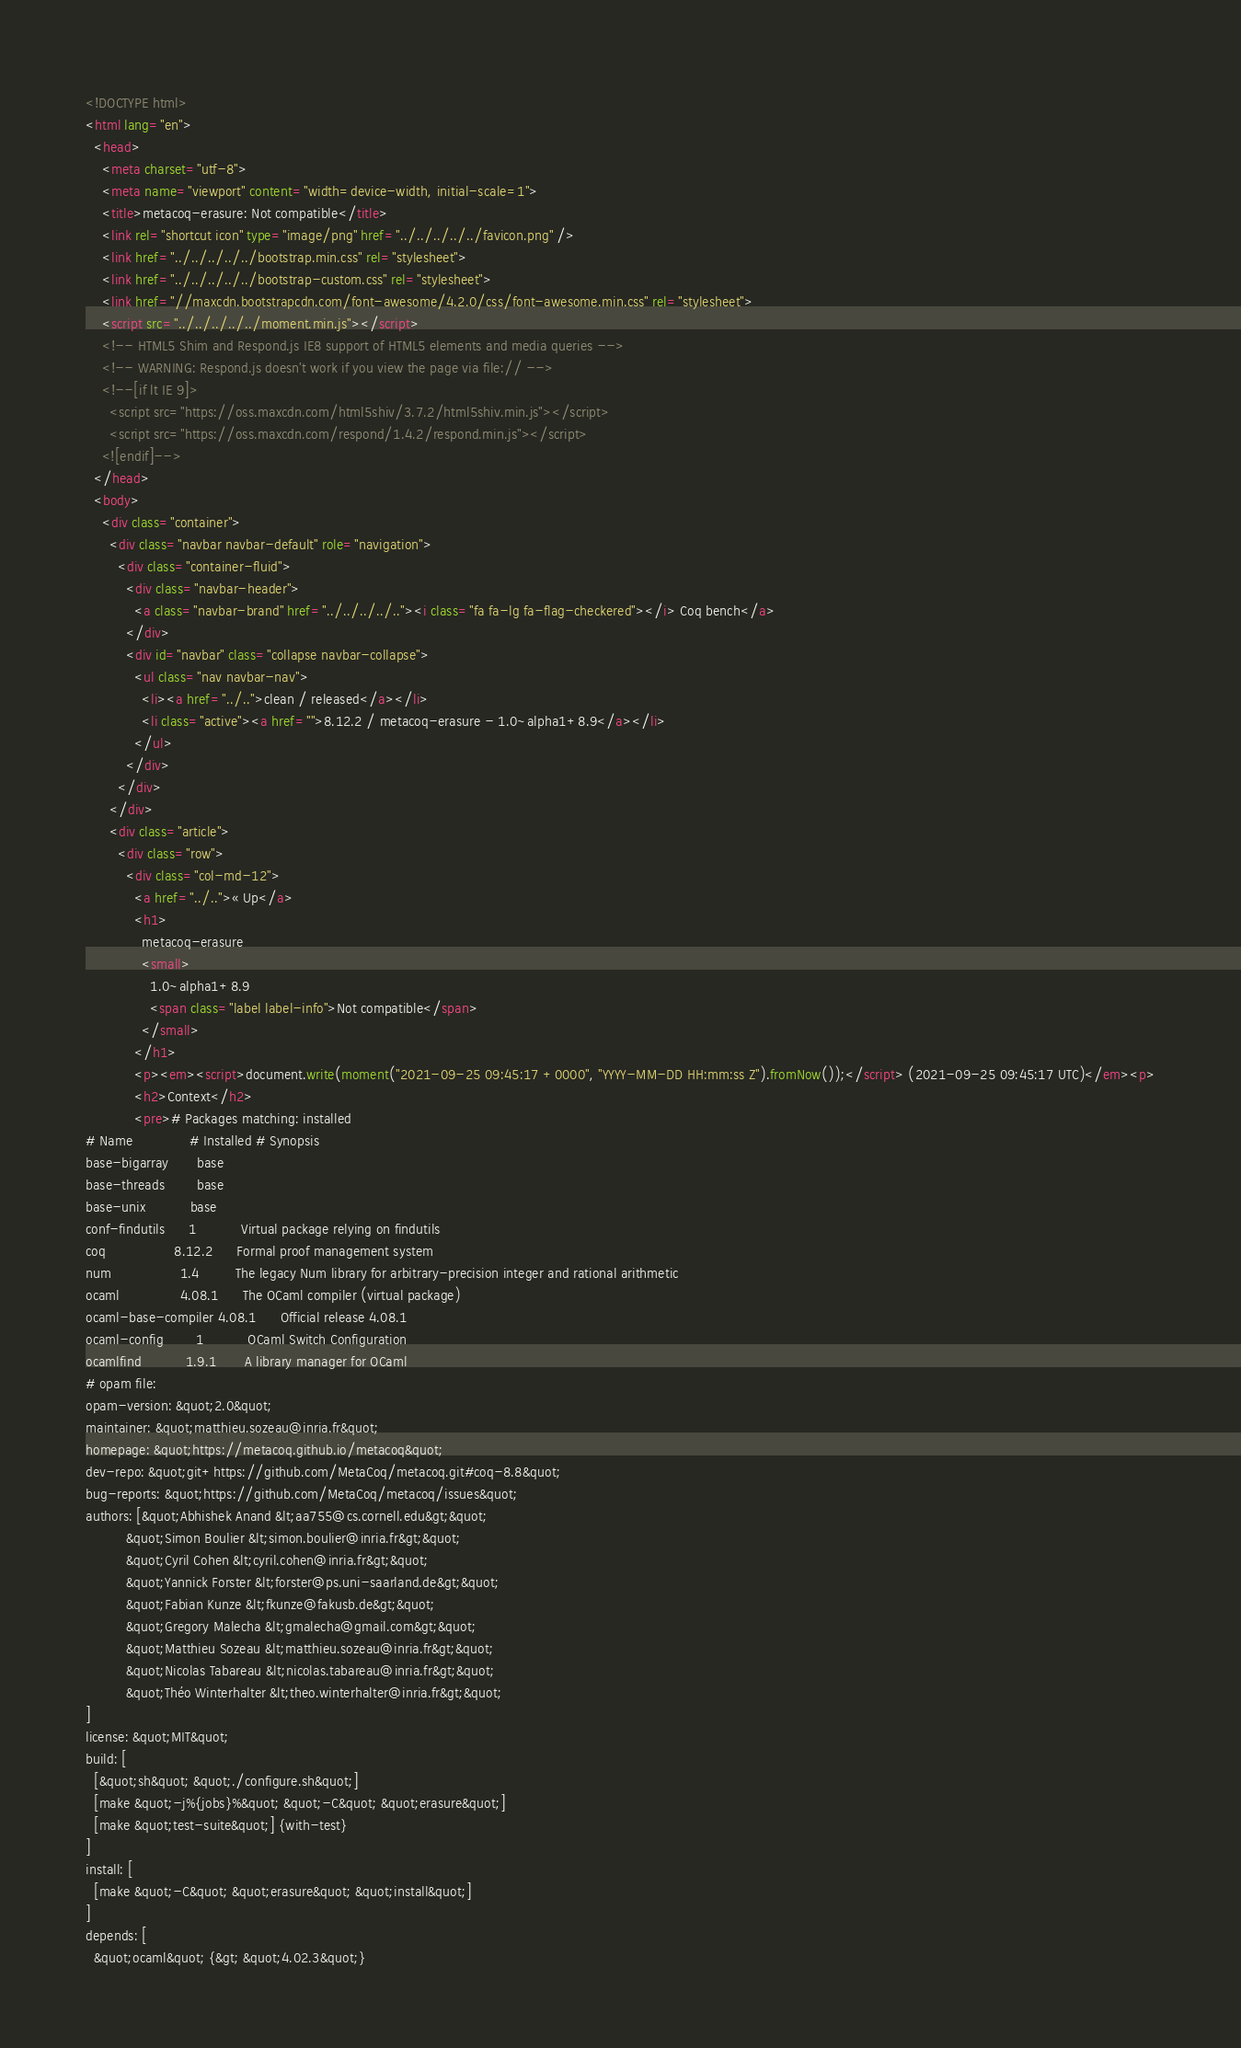<code> <loc_0><loc_0><loc_500><loc_500><_HTML_><!DOCTYPE html>
<html lang="en">
  <head>
    <meta charset="utf-8">
    <meta name="viewport" content="width=device-width, initial-scale=1">
    <title>metacoq-erasure: Not compatible</title>
    <link rel="shortcut icon" type="image/png" href="../../../../../favicon.png" />
    <link href="../../../../../bootstrap.min.css" rel="stylesheet">
    <link href="../../../../../bootstrap-custom.css" rel="stylesheet">
    <link href="//maxcdn.bootstrapcdn.com/font-awesome/4.2.0/css/font-awesome.min.css" rel="stylesheet">
    <script src="../../../../../moment.min.js"></script>
    <!-- HTML5 Shim and Respond.js IE8 support of HTML5 elements and media queries -->
    <!-- WARNING: Respond.js doesn't work if you view the page via file:// -->
    <!--[if lt IE 9]>
      <script src="https://oss.maxcdn.com/html5shiv/3.7.2/html5shiv.min.js"></script>
      <script src="https://oss.maxcdn.com/respond/1.4.2/respond.min.js"></script>
    <![endif]-->
  </head>
  <body>
    <div class="container">
      <div class="navbar navbar-default" role="navigation">
        <div class="container-fluid">
          <div class="navbar-header">
            <a class="navbar-brand" href="../../../../.."><i class="fa fa-lg fa-flag-checkered"></i> Coq bench</a>
          </div>
          <div id="navbar" class="collapse navbar-collapse">
            <ul class="nav navbar-nav">
              <li><a href="../..">clean / released</a></li>
              <li class="active"><a href="">8.12.2 / metacoq-erasure - 1.0~alpha1+8.9</a></li>
            </ul>
          </div>
        </div>
      </div>
      <div class="article">
        <div class="row">
          <div class="col-md-12">
            <a href="../..">« Up</a>
            <h1>
              metacoq-erasure
              <small>
                1.0~alpha1+8.9
                <span class="label label-info">Not compatible</span>
              </small>
            </h1>
            <p><em><script>document.write(moment("2021-09-25 09:45:17 +0000", "YYYY-MM-DD HH:mm:ss Z").fromNow());</script> (2021-09-25 09:45:17 UTC)</em><p>
            <h2>Context</h2>
            <pre># Packages matching: installed
# Name              # Installed # Synopsis
base-bigarray       base
base-threads        base
base-unix           base
conf-findutils      1           Virtual package relying on findutils
coq                 8.12.2      Formal proof management system
num                 1.4         The legacy Num library for arbitrary-precision integer and rational arithmetic
ocaml               4.08.1      The OCaml compiler (virtual package)
ocaml-base-compiler 4.08.1      Official release 4.08.1
ocaml-config        1           OCaml Switch Configuration
ocamlfind           1.9.1       A library manager for OCaml
# opam file:
opam-version: &quot;2.0&quot;
maintainer: &quot;matthieu.sozeau@inria.fr&quot;
homepage: &quot;https://metacoq.github.io/metacoq&quot;
dev-repo: &quot;git+https://github.com/MetaCoq/metacoq.git#coq-8.8&quot;
bug-reports: &quot;https://github.com/MetaCoq/metacoq/issues&quot;
authors: [&quot;Abhishek Anand &lt;aa755@cs.cornell.edu&gt;&quot;
          &quot;Simon Boulier &lt;simon.boulier@inria.fr&gt;&quot;
          &quot;Cyril Cohen &lt;cyril.cohen@inria.fr&gt;&quot;
          &quot;Yannick Forster &lt;forster@ps.uni-saarland.de&gt;&quot;
          &quot;Fabian Kunze &lt;fkunze@fakusb.de&gt;&quot;
          &quot;Gregory Malecha &lt;gmalecha@gmail.com&gt;&quot;
          &quot;Matthieu Sozeau &lt;matthieu.sozeau@inria.fr&gt;&quot;
          &quot;Nicolas Tabareau &lt;nicolas.tabareau@inria.fr&gt;&quot;
          &quot;Théo Winterhalter &lt;theo.winterhalter@inria.fr&gt;&quot;
]
license: &quot;MIT&quot;
build: [
  [&quot;sh&quot; &quot;./configure.sh&quot;]
  [make &quot;-j%{jobs}%&quot; &quot;-C&quot; &quot;erasure&quot;]
  [make &quot;test-suite&quot;] {with-test}
]
install: [
  [make &quot;-C&quot; &quot;erasure&quot; &quot;install&quot;]
]
depends: [
  &quot;ocaml&quot; {&gt; &quot;4.02.3&quot;}</code> 